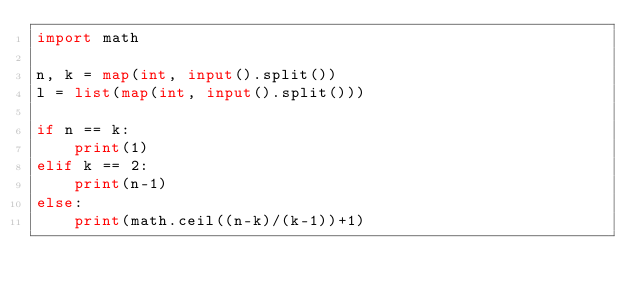<code> <loc_0><loc_0><loc_500><loc_500><_Python_>import math

n, k = map(int, input().split())
l = list(map(int, input().split()))

if n == k:
    print(1)
elif k == 2:
    print(n-1)
else:
    print(math.ceil((n-k)/(k-1))+1)</code> 